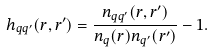Convert formula to latex. <formula><loc_0><loc_0><loc_500><loc_500>h _ { q q ^ { \prime } } ( { r } , { r } ^ { \prime } ) = \frac { n _ { q q ^ { \prime } } ( { r } , { r } ^ { \prime } ) } { n _ { q } ( { r } ) n _ { q ^ { \prime } } ( { r } ^ { \prime } ) } - 1 .</formula> 